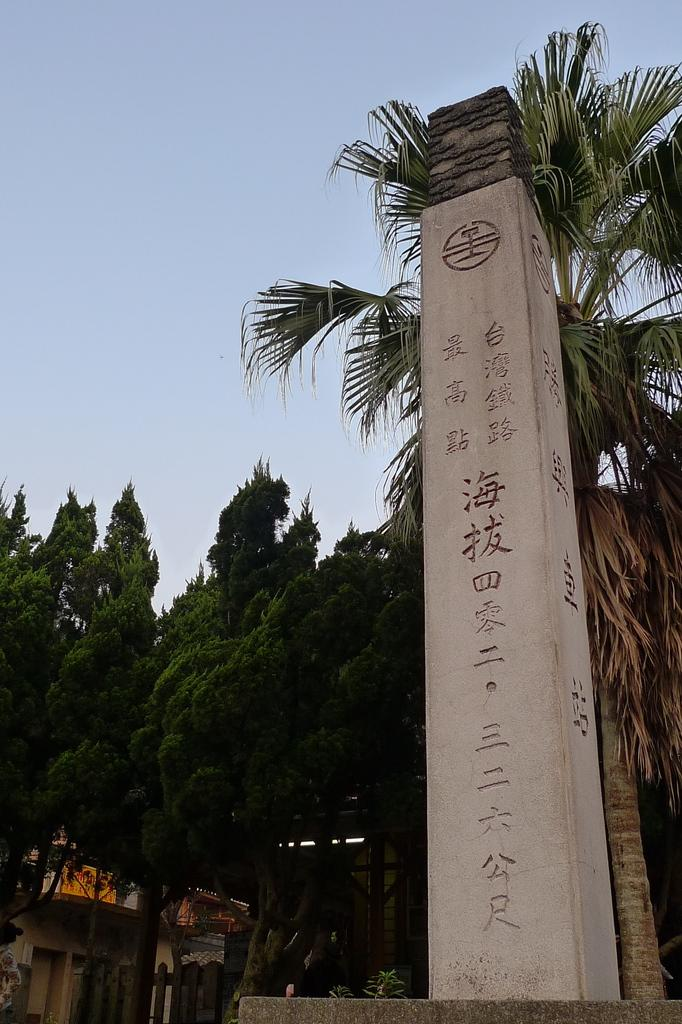What type of structures can be seen in the image? There are buildings in the image. What natural elements are present in the image? There are trees in the image. What architectural feature can be seen in the image? There is a pillar in the image. What type of barrier is visible in the image? There is a fence in the image. What part of the environment is visible in the image? The sky is visible in the image. Based on the presence of the sky and the absence of any artificial light sources, can we infer the time of day the image was taken? Yes, the image was likely taken during the day. What type of coastline can be seen in the image? There is no coastline present in the image; it features buildings, trees, a pillar, a fence, and the sky. What type of office furniture is visible in the image? There is no office furniture present in the image. 